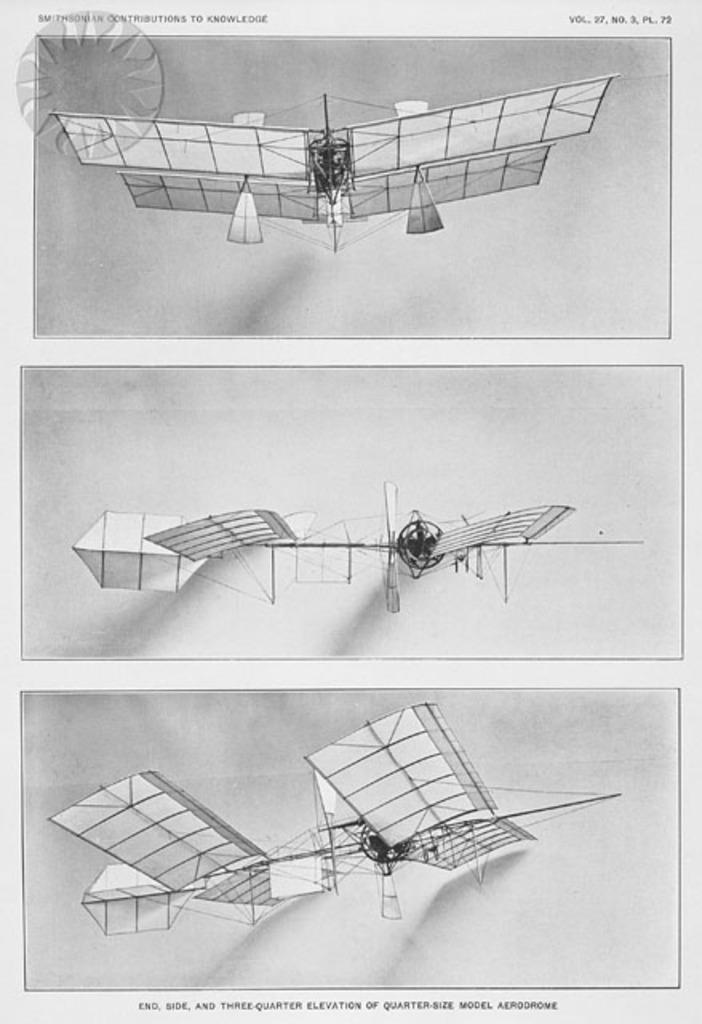<image>
Present a compact description of the photo's key features. A model airplane from Vol 27 of Smithsonian Contributions to Knowledge is seen 